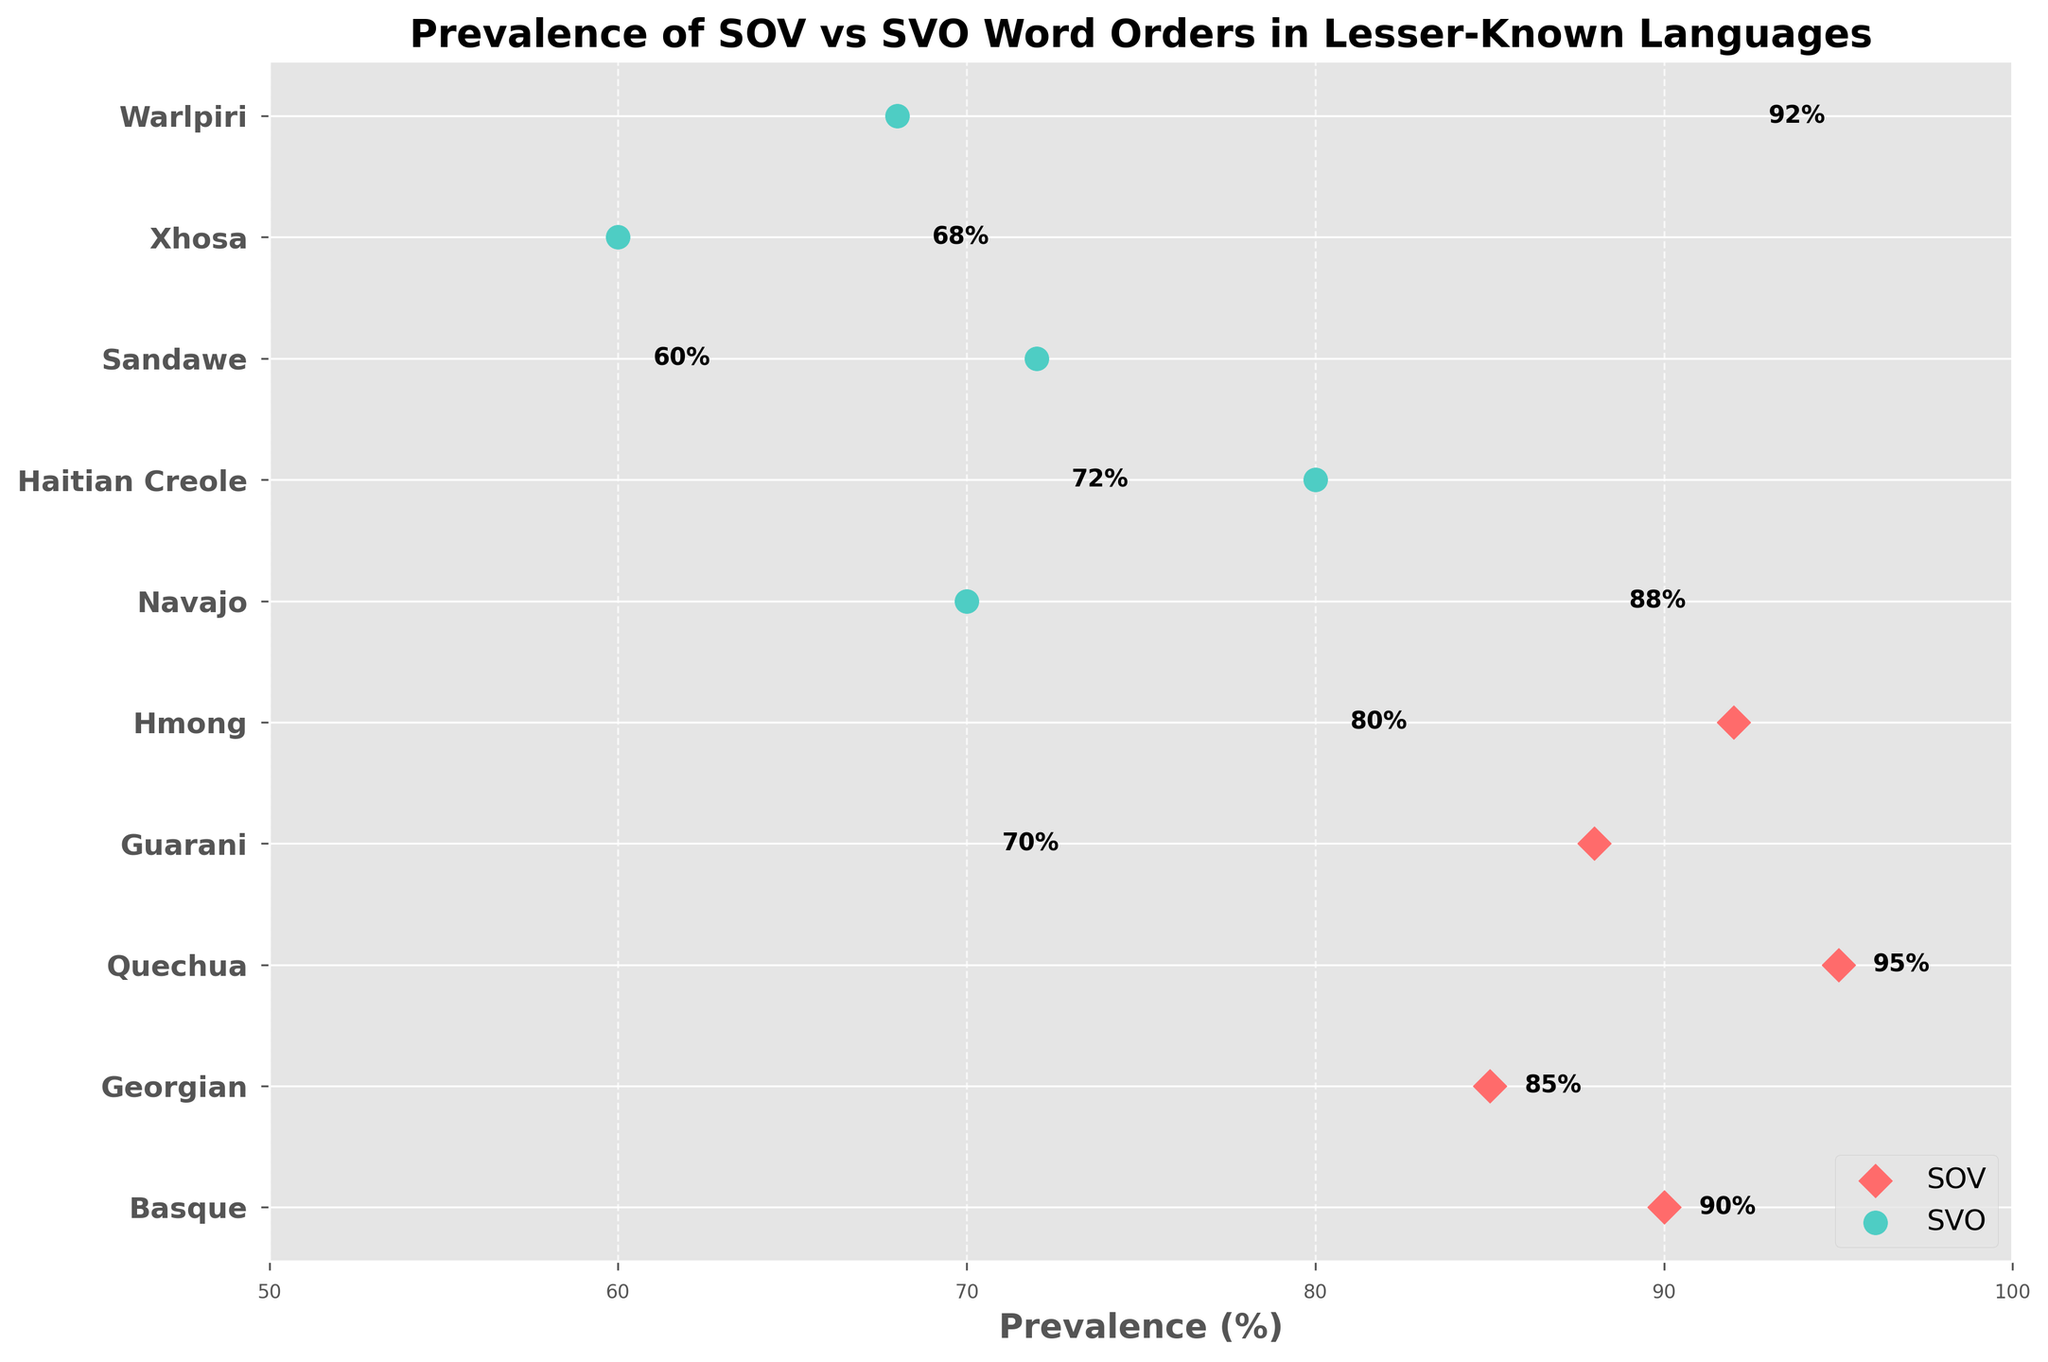what type of word order has the highest prevalence overall? Locate the highest percentage point across both the SOV and SVO word orders. The highest value is with Quechua having an SOV order at 95%.
Answer: SOV What's the prevalence of the SVO word order for Haitian Creole? Refer to the prevalence percentage next to the dot for Haitian Creole in the figure (which is an SVO language marked with a circle).
Answer: 72% Which language has the lowest prevalence of SVO word order? Compare the prevalence percentages of all the SVO languages (Guarani, Hmong, Haitian Creole, Sandawe, Xhosa) and identify the lowest value. Sandawe has 60%.
Answer: Sandawe How many languages are represented in the figure? Count the total number of unique languages listed on the y-axis.
Answer: 10 What is the range of prevalence percentages for SOV languages? Identify the minimum and maximum prevalence percentages within the SOV group. The minimum is 85% (Georgian) and the maximum is 95% (Quechua). So, the range is 95% - 85%.
Answer: 10% Which word order has more languages with a prevalence above 80%? Compare the number of languages with above 80% prevalence in both SOV and SVO groups. SOV: 5 languages (Basque, Georgian, Quechua, Navajo, Warlpiri). SVO: 2 languages (Hmong, Guarani).
Answer: SOV Which language with an SOV word order has the second highest prevalence? Identify the languages with SOV word order and rank their prevalence percentages. The second highest prevalence is 92% for Warlpiri.
Answer: Warlpiri What is the average prevalence of the SVO word order? Sum the prevalence percentages of the SVO languages (70, 80, 72, 60, 68) and divide by the number of SVO languages. (70 + 80 + 72 + 60 + 68) / 5 = 70%.
Answer: 70% What is the difference in prevalence between the highest SOV and the highest SVO language? Identify the highest prevalence for both word orders (SOV: Quechua at 95%, SVO: Hmong at 80%) and subtract the SVO highest from the SOV highest. 95% - 80% = 15%.
Answer: 15% 